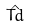Convert formula to latex. <formula><loc_0><loc_0><loc_500><loc_500>\hat { T d }</formula> 